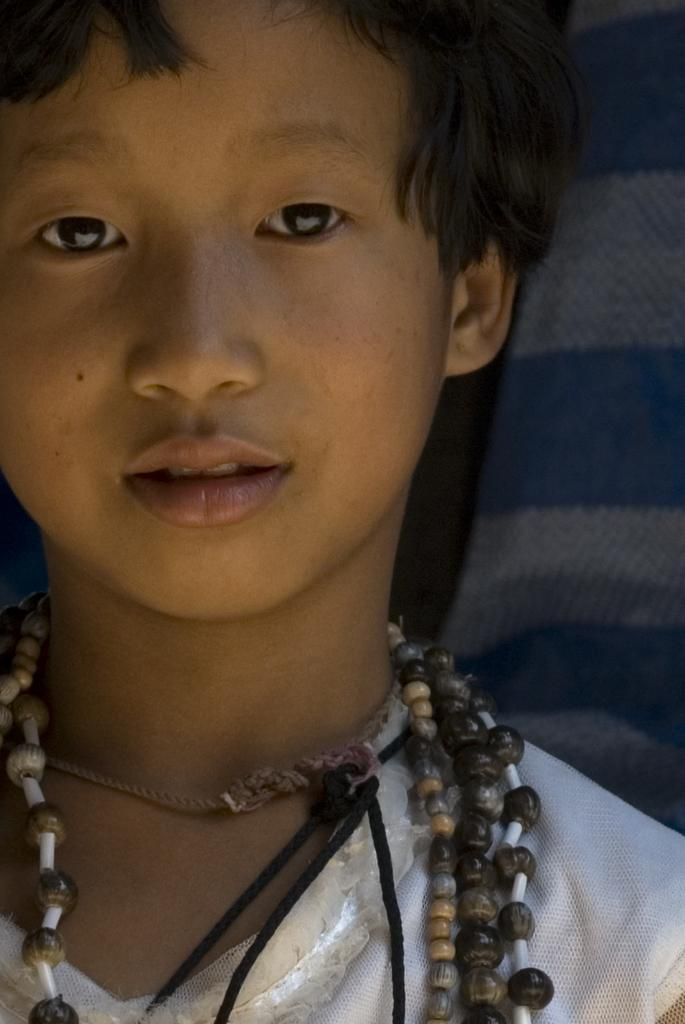What is the main subject of the image? There is a person in the image. What is the person wearing? The person is wearing a white dress. What is the person doing in the image? The person is looking at a picture. What can be seen in the background of the image? There is a cloth in the background of the image. What colors are present on the cloth? The cloth has white and blue colors. Can you tell me how many monkeys are pushing things in the image? There are no monkeys present in the image, nor is there any pushing of things. 